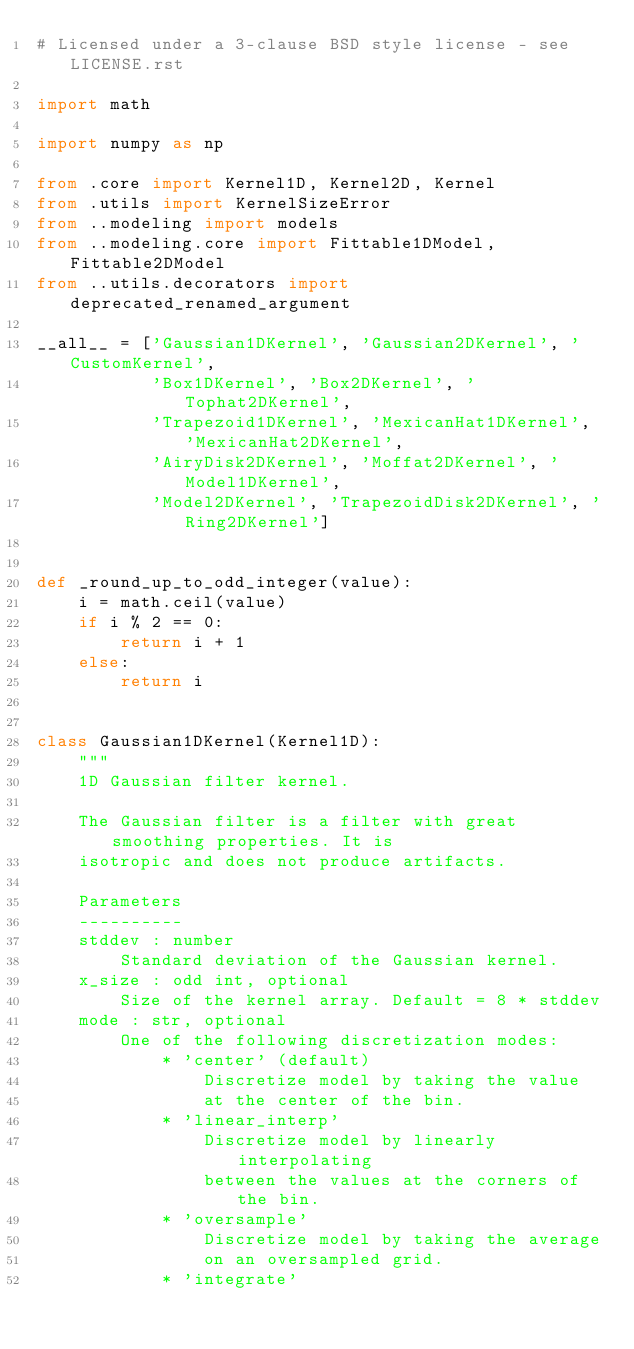Convert code to text. <code><loc_0><loc_0><loc_500><loc_500><_Python_># Licensed under a 3-clause BSD style license - see LICENSE.rst

import math

import numpy as np

from .core import Kernel1D, Kernel2D, Kernel
from .utils import KernelSizeError
from ..modeling import models
from ..modeling.core import Fittable1DModel, Fittable2DModel
from ..utils.decorators import deprecated_renamed_argument

__all__ = ['Gaussian1DKernel', 'Gaussian2DKernel', 'CustomKernel',
           'Box1DKernel', 'Box2DKernel', 'Tophat2DKernel',
           'Trapezoid1DKernel', 'MexicanHat1DKernel', 'MexicanHat2DKernel',
           'AiryDisk2DKernel', 'Moffat2DKernel', 'Model1DKernel',
           'Model2DKernel', 'TrapezoidDisk2DKernel', 'Ring2DKernel']


def _round_up_to_odd_integer(value):
    i = math.ceil(value)
    if i % 2 == 0:
        return i + 1
    else:
        return i


class Gaussian1DKernel(Kernel1D):
    """
    1D Gaussian filter kernel.

    The Gaussian filter is a filter with great smoothing properties. It is
    isotropic and does not produce artifacts.

    Parameters
    ----------
    stddev : number
        Standard deviation of the Gaussian kernel.
    x_size : odd int, optional
        Size of the kernel array. Default = 8 * stddev
    mode : str, optional
        One of the following discretization modes:
            * 'center' (default)
                Discretize model by taking the value
                at the center of the bin.
            * 'linear_interp'
                Discretize model by linearly interpolating
                between the values at the corners of the bin.
            * 'oversample'
                Discretize model by taking the average
                on an oversampled grid.
            * 'integrate'</code> 